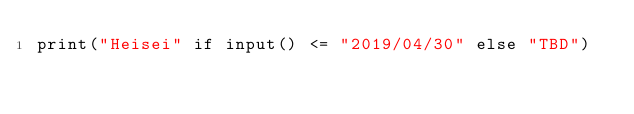<code> <loc_0><loc_0><loc_500><loc_500><_Python_>print("Heisei" if input() <= "2019/04/30" else "TBD")
</code> 